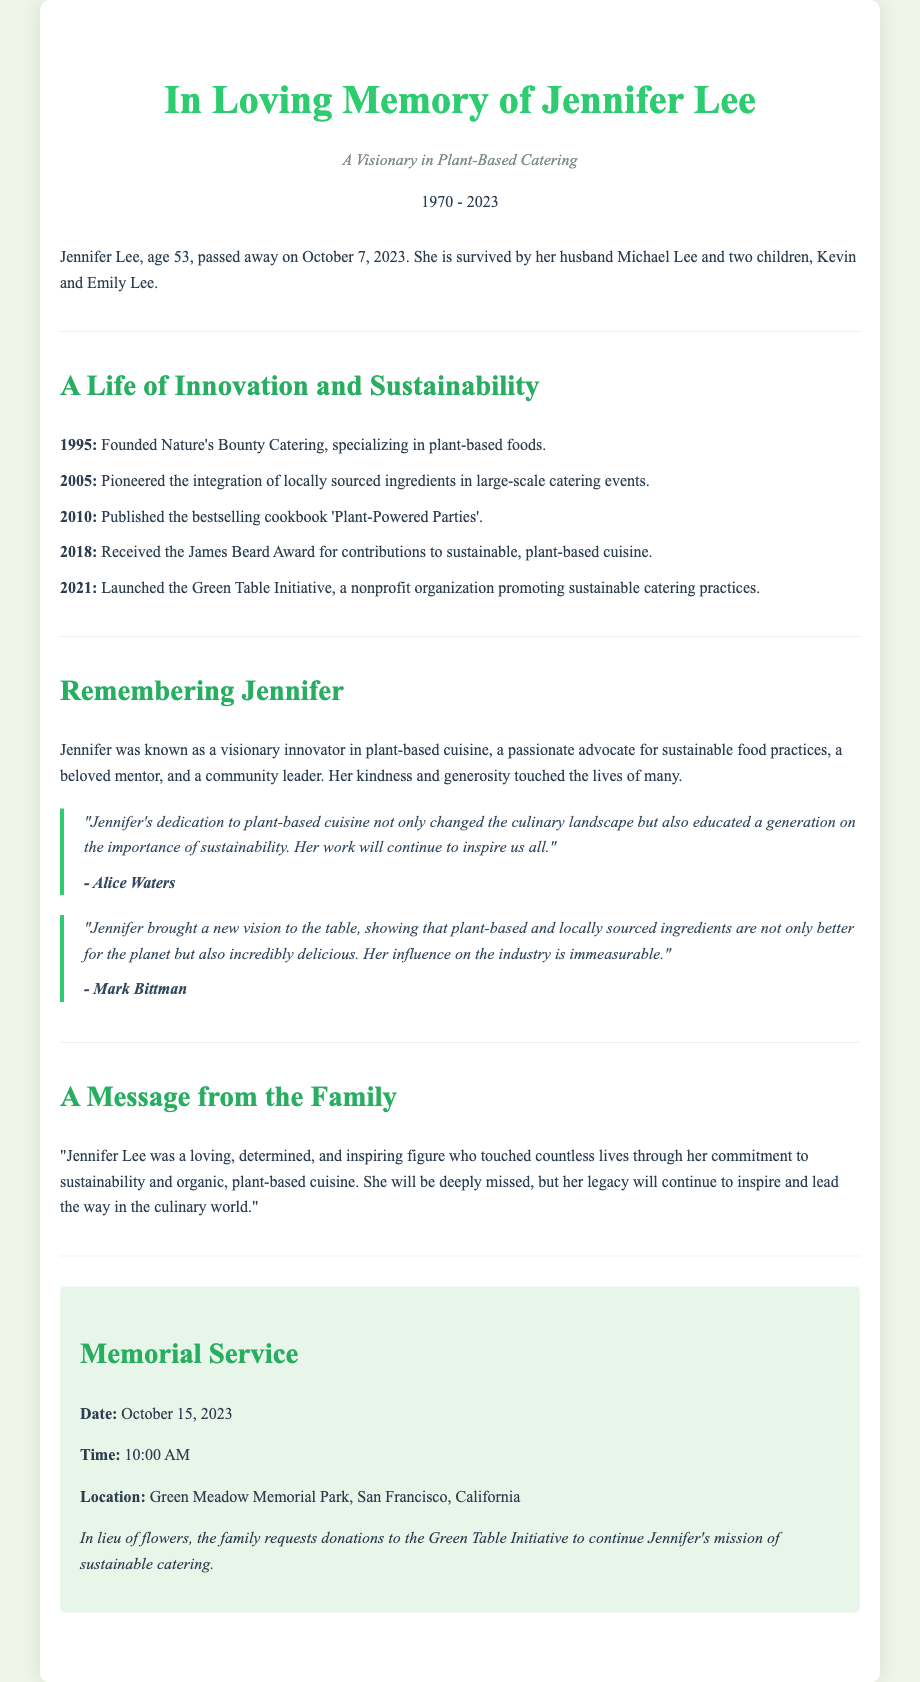What was Jennifer Lee’s age at the time of her passing? The document states that Jennifer Lee passed away at the age of 53.
Answer: 53 What year did Jennifer Lee found Nature's Bounty Catering? The document lists 1995 as the year Jennifer founded Nature's Bounty Catering.
Answer: 1995 What award did Jennifer receive in 2018? The document mentions that Jennifer received the James Beard Award in 2018 for her contributions to sustainable, plant-based cuisine.
Answer: James Beard Award Where will the memorial service be held? According to the document, the memorial service will be held at Green Meadow Memorial Park, San Francisco, California.
Answer: Green Meadow Memorial Park, San Francisco, California In what year was the Green Table Initiative launched? The document indicates that the Green Table Initiative was launched in 2021.
Answer: 2021 What was a significant contribution of Jennifer Lee to the culinary world according to Alice Waters? Alice Waters highlighted that Jennifer's dedication to plant-based cuisine educated a generation on sustainability.
Answer: Education on sustainability What date is the memorial service scheduled for? The document specifies that the memorial service is set for October 15, 2023.
Answer: October 15, 2023 How did Jennifer Lee influence the industry according to Mark Bittman? Mark Bittman stated that Jennifer showed that plant-based and locally sourced ingredients are better for the planet and delicious.
Answer: Better for the planet and delicious What is requested in lieu of flowers? The document requests that donations be made to the Green Table Initiative in lieu of flowers.
Answer: Donations to the Green Table Initiative 